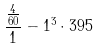<formula> <loc_0><loc_0><loc_500><loc_500>\frac { \frac { 4 } { 6 0 } } { 1 } - 1 ^ { 3 } \cdot 3 9 5</formula> 